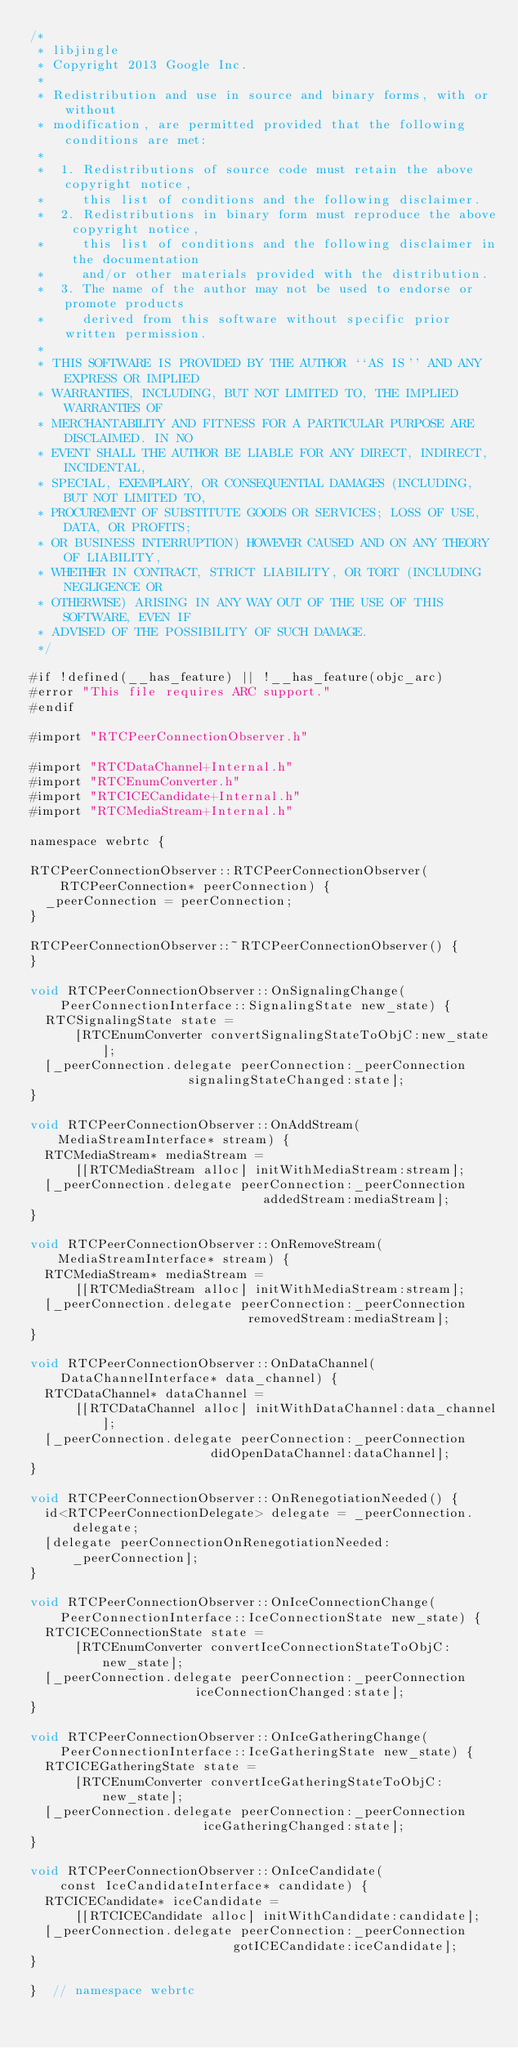Convert code to text. <code><loc_0><loc_0><loc_500><loc_500><_ObjectiveC_>/*
 * libjingle
 * Copyright 2013 Google Inc.
 *
 * Redistribution and use in source and binary forms, with or without
 * modification, are permitted provided that the following conditions are met:
 *
 *  1. Redistributions of source code must retain the above copyright notice,
 *     this list of conditions and the following disclaimer.
 *  2. Redistributions in binary form must reproduce the above copyright notice,
 *     this list of conditions and the following disclaimer in the documentation
 *     and/or other materials provided with the distribution.
 *  3. The name of the author may not be used to endorse or promote products
 *     derived from this software without specific prior written permission.
 *
 * THIS SOFTWARE IS PROVIDED BY THE AUTHOR ``AS IS'' AND ANY EXPRESS OR IMPLIED
 * WARRANTIES, INCLUDING, BUT NOT LIMITED TO, THE IMPLIED WARRANTIES OF
 * MERCHANTABILITY AND FITNESS FOR A PARTICULAR PURPOSE ARE DISCLAIMED. IN NO
 * EVENT SHALL THE AUTHOR BE LIABLE FOR ANY DIRECT, INDIRECT, INCIDENTAL,
 * SPECIAL, EXEMPLARY, OR CONSEQUENTIAL DAMAGES (INCLUDING, BUT NOT LIMITED TO,
 * PROCUREMENT OF SUBSTITUTE GOODS OR SERVICES; LOSS OF USE, DATA, OR PROFITS;
 * OR BUSINESS INTERRUPTION) HOWEVER CAUSED AND ON ANY THEORY OF LIABILITY,
 * WHETHER IN CONTRACT, STRICT LIABILITY, OR TORT (INCLUDING NEGLIGENCE OR
 * OTHERWISE) ARISING IN ANY WAY OUT OF THE USE OF THIS SOFTWARE, EVEN IF
 * ADVISED OF THE POSSIBILITY OF SUCH DAMAGE.
 */

#if !defined(__has_feature) || !__has_feature(objc_arc)
#error "This file requires ARC support."
#endif

#import "RTCPeerConnectionObserver.h"

#import "RTCDataChannel+Internal.h"
#import "RTCEnumConverter.h"
#import "RTCICECandidate+Internal.h"
#import "RTCMediaStream+Internal.h"

namespace webrtc {

RTCPeerConnectionObserver::RTCPeerConnectionObserver(
    RTCPeerConnection* peerConnection) {
  _peerConnection = peerConnection;
}

RTCPeerConnectionObserver::~RTCPeerConnectionObserver() {
}

void RTCPeerConnectionObserver::OnSignalingChange(
    PeerConnectionInterface::SignalingState new_state) {
  RTCSignalingState state =
      [RTCEnumConverter convertSignalingStateToObjC:new_state];
  [_peerConnection.delegate peerConnection:_peerConnection
                     signalingStateChanged:state];
}

void RTCPeerConnectionObserver::OnAddStream(MediaStreamInterface* stream) {
  RTCMediaStream* mediaStream =
      [[RTCMediaStream alloc] initWithMediaStream:stream];
  [_peerConnection.delegate peerConnection:_peerConnection
                               addedStream:mediaStream];
}

void RTCPeerConnectionObserver::OnRemoveStream(MediaStreamInterface* stream) {
  RTCMediaStream* mediaStream =
      [[RTCMediaStream alloc] initWithMediaStream:stream];
  [_peerConnection.delegate peerConnection:_peerConnection
                             removedStream:mediaStream];
}

void RTCPeerConnectionObserver::OnDataChannel(
    DataChannelInterface* data_channel) {
  RTCDataChannel* dataChannel =
      [[RTCDataChannel alloc] initWithDataChannel:data_channel];
  [_peerConnection.delegate peerConnection:_peerConnection
                        didOpenDataChannel:dataChannel];
}

void RTCPeerConnectionObserver::OnRenegotiationNeeded() {
  id<RTCPeerConnectionDelegate> delegate = _peerConnection.delegate;
  [delegate peerConnectionOnRenegotiationNeeded:_peerConnection];
}

void RTCPeerConnectionObserver::OnIceConnectionChange(
    PeerConnectionInterface::IceConnectionState new_state) {
  RTCICEConnectionState state =
      [RTCEnumConverter convertIceConnectionStateToObjC:new_state];
  [_peerConnection.delegate peerConnection:_peerConnection
                      iceConnectionChanged:state];
}

void RTCPeerConnectionObserver::OnIceGatheringChange(
    PeerConnectionInterface::IceGatheringState new_state) {
  RTCICEGatheringState state =
      [RTCEnumConverter convertIceGatheringStateToObjC:new_state];
  [_peerConnection.delegate peerConnection:_peerConnection
                       iceGatheringChanged:state];
}

void RTCPeerConnectionObserver::OnIceCandidate(
    const IceCandidateInterface* candidate) {
  RTCICECandidate* iceCandidate =
      [[RTCICECandidate alloc] initWithCandidate:candidate];
  [_peerConnection.delegate peerConnection:_peerConnection
                           gotICECandidate:iceCandidate];
}

}  // namespace webrtc
</code> 